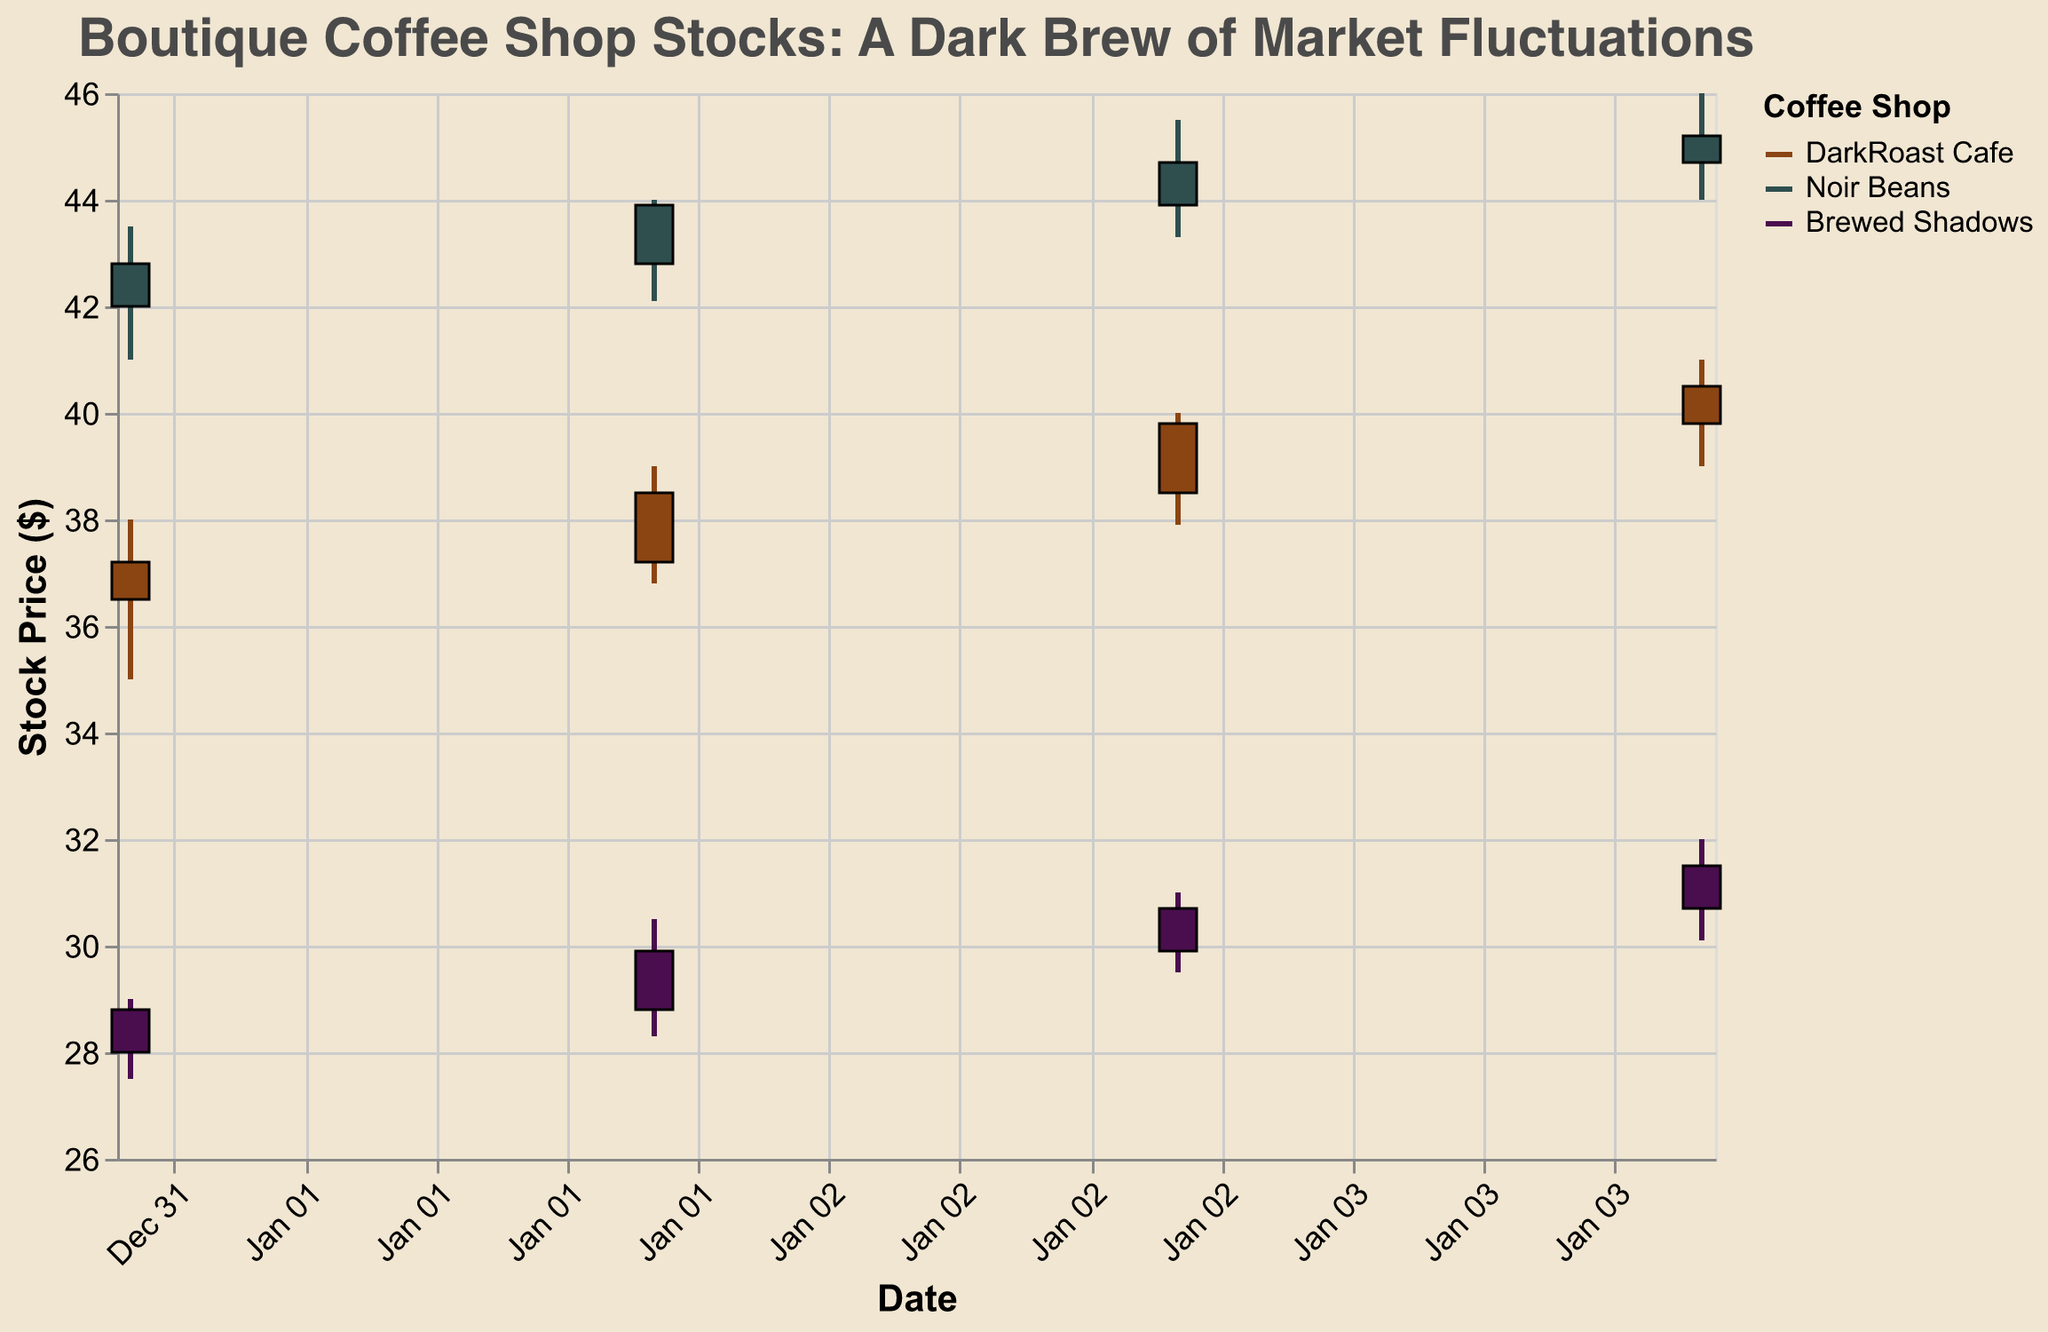Which coffee shop had the highest stock price on January 3rd? Looking at the candlestick plot, we observe that on January 3rd, Noir Beans had the highest closing price of 44.70 among all plotted data.
Answer: Noir Beans Which coffee shop showed the most significant closing price increase from January 1st to January 4th? To determine this, we check the closing prices on January 1st and 4th for each coffee shop:
- DarkRoast Cafe: 37.20 to 40.50, increase of 3.30
- Noir Beans: 42.80 to 45.20, increase of 2.40
- Brewed Shadows: 28.80 to 31.50, increase of 2.70
DarkRoast Cafe had the most significant increase.
Answer: DarkRoast Cafe What was the closing price on January 2nd for Brewed Shadows? We look at the plot for the closing price of Brewed Shadows on January 2nd, which is 29.90.
Answer: 29.90 Compare the opening and closing prices on January 4th for Noir Beans. Was the closing price higher or lower than the opening price? On January 4th, Noir Beans had an opening price of 44.70 and a closing price of 45.20. Since 45.20 is higher than 44.70, the closing price was higher.
Answer: Higher Calculate the average closing price for DarkRoast Cafe over the provided dates. To find the average, sum up the closing prices for DarkRoast Cafe (37.20, 38.50, 39.80, 40.50) and divide by the number of observations:
(37.20 + 38.50 + 39.80 + 40.50) / 4 = 39.00
Answer: 39.00 Which coffee shop experienced the highest volatility (difference between high and low prices) on January 3rd? We note the high and low prices on January 3rd for each coffee shop:
- DarkRoast Cafe: 40.00 - 37.90 = 2.10
- Noir Beans: 45.50 - 43.30 = 2.20
- Brewed Shadows: 31.00 - 29.50 = 1.50
Noir Beans experienced the highest volatility.
Answer: Noir Beans What is the overall trend of DarkRoast Cafe's closing prices over the observed dates? Referring to the plot, we see that DarkRoast Cafe's closing prices increase gradually from 37.20 on January 1st to 40.50 on January 4th.
Answer: Increasing How does the volume of shares traded on January 2nd compare across the three coffee shops? Looking at the trading volume on January 2nd:
- DarkRoast Cafe: 1600
- Noir Beans: 1850
- Brewed Shadows: 1300
Noir Beans had the highest trading volume, followed by DarkRoast Cafe, then Brewed Shadows.
Answer: Noir Beans > DarkRoast Cafe > Brewed Shadows Which store had the lowest opening price on January 1st? On January 1st, the opening prices are:
- DarkRoast Cafe: 36.50
- Noir Beans: 42.00
- Brewed Shadows: 28.00
Brewed Shadows had the lowest opening price.
Answer: Brewed Shadows 